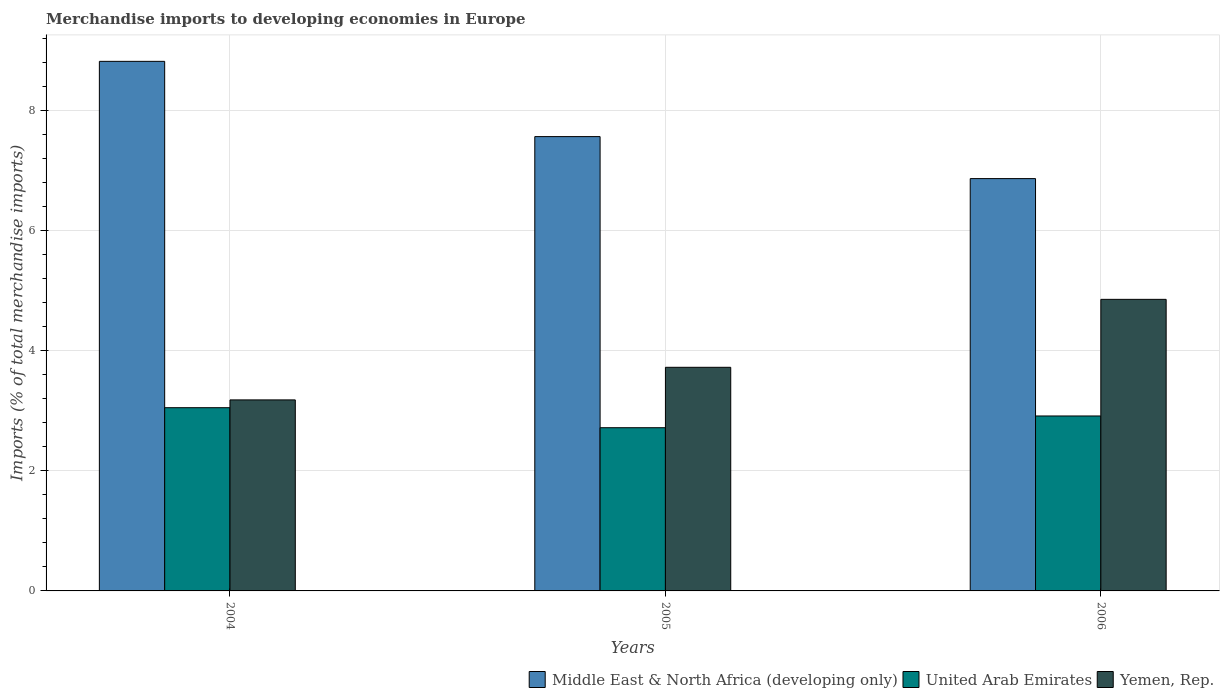How many groups of bars are there?
Offer a terse response. 3. How many bars are there on the 3rd tick from the left?
Provide a succinct answer. 3. How many bars are there on the 3rd tick from the right?
Make the answer very short. 3. What is the percentage total merchandise imports in Middle East & North Africa (developing only) in 2006?
Your response must be concise. 6.87. Across all years, what is the maximum percentage total merchandise imports in Yemen, Rep.?
Your answer should be compact. 4.86. Across all years, what is the minimum percentage total merchandise imports in Yemen, Rep.?
Your answer should be very brief. 3.18. In which year was the percentage total merchandise imports in United Arab Emirates maximum?
Ensure brevity in your answer.  2004. In which year was the percentage total merchandise imports in Middle East & North Africa (developing only) minimum?
Provide a short and direct response. 2006. What is the total percentage total merchandise imports in Yemen, Rep. in the graph?
Keep it short and to the point. 11.76. What is the difference between the percentage total merchandise imports in Middle East & North Africa (developing only) in 2004 and that in 2005?
Your answer should be very brief. 1.25. What is the difference between the percentage total merchandise imports in United Arab Emirates in 2005 and the percentage total merchandise imports in Middle East & North Africa (developing only) in 2004?
Provide a short and direct response. -6.1. What is the average percentage total merchandise imports in Middle East & North Africa (developing only) per year?
Provide a succinct answer. 7.75. In the year 2004, what is the difference between the percentage total merchandise imports in United Arab Emirates and percentage total merchandise imports in Yemen, Rep.?
Ensure brevity in your answer.  -0.13. What is the ratio of the percentage total merchandise imports in Middle East & North Africa (developing only) in 2004 to that in 2006?
Your response must be concise. 1.28. Is the difference between the percentage total merchandise imports in United Arab Emirates in 2005 and 2006 greater than the difference between the percentage total merchandise imports in Yemen, Rep. in 2005 and 2006?
Provide a short and direct response. Yes. What is the difference between the highest and the second highest percentage total merchandise imports in Middle East & North Africa (developing only)?
Give a very brief answer. 1.25. What is the difference between the highest and the lowest percentage total merchandise imports in Yemen, Rep.?
Your answer should be very brief. 1.67. In how many years, is the percentage total merchandise imports in Yemen, Rep. greater than the average percentage total merchandise imports in Yemen, Rep. taken over all years?
Provide a short and direct response. 1. Is the sum of the percentage total merchandise imports in United Arab Emirates in 2005 and 2006 greater than the maximum percentage total merchandise imports in Middle East & North Africa (developing only) across all years?
Provide a succinct answer. No. What does the 1st bar from the left in 2006 represents?
Your answer should be very brief. Middle East & North Africa (developing only). What does the 1st bar from the right in 2006 represents?
Your answer should be compact. Yemen, Rep. Is it the case that in every year, the sum of the percentage total merchandise imports in Yemen, Rep. and percentage total merchandise imports in United Arab Emirates is greater than the percentage total merchandise imports in Middle East & North Africa (developing only)?
Give a very brief answer. No. Are all the bars in the graph horizontal?
Provide a short and direct response. No. What is the difference between two consecutive major ticks on the Y-axis?
Your response must be concise. 2. Are the values on the major ticks of Y-axis written in scientific E-notation?
Your response must be concise. No. How are the legend labels stacked?
Offer a terse response. Horizontal. What is the title of the graph?
Provide a short and direct response. Merchandise imports to developing economies in Europe. Does "Kenya" appear as one of the legend labels in the graph?
Provide a succinct answer. No. What is the label or title of the Y-axis?
Offer a terse response. Imports (% of total merchandise imports). What is the Imports (% of total merchandise imports) of Middle East & North Africa (developing only) in 2004?
Ensure brevity in your answer.  8.82. What is the Imports (% of total merchandise imports) in United Arab Emirates in 2004?
Your answer should be very brief. 3.05. What is the Imports (% of total merchandise imports) in Yemen, Rep. in 2004?
Keep it short and to the point. 3.18. What is the Imports (% of total merchandise imports) in Middle East & North Africa (developing only) in 2005?
Your answer should be compact. 7.57. What is the Imports (% of total merchandise imports) in United Arab Emirates in 2005?
Your response must be concise. 2.72. What is the Imports (% of total merchandise imports) in Yemen, Rep. in 2005?
Provide a short and direct response. 3.72. What is the Imports (% of total merchandise imports) in Middle East & North Africa (developing only) in 2006?
Provide a short and direct response. 6.87. What is the Imports (% of total merchandise imports) in United Arab Emirates in 2006?
Provide a succinct answer. 2.91. What is the Imports (% of total merchandise imports) of Yemen, Rep. in 2006?
Make the answer very short. 4.86. Across all years, what is the maximum Imports (% of total merchandise imports) in Middle East & North Africa (developing only)?
Keep it short and to the point. 8.82. Across all years, what is the maximum Imports (% of total merchandise imports) in United Arab Emirates?
Provide a short and direct response. 3.05. Across all years, what is the maximum Imports (% of total merchandise imports) in Yemen, Rep.?
Make the answer very short. 4.86. Across all years, what is the minimum Imports (% of total merchandise imports) of Middle East & North Africa (developing only)?
Provide a short and direct response. 6.87. Across all years, what is the minimum Imports (% of total merchandise imports) in United Arab Emirates?
Provide a short and direct response. 2.72. Across all years, what is the minimum Imports (% of total merchandise imports) in Yemen, Rep.?
Provide a short and direct response. 3.18. What is the total Imports (% of total merchandise imports) of Middle East & North Africa (developing only) in the graph?
Your answer should be compact. 23.25. What is the total Imports (% of total merchandise imports) of United Arab Emirates in the graph?
Provide a short and direct response. 8.68. What is the total Imports (% of total merchandise imports) of Yemen, Rep. in the graph?
Make the answer very short. 11.76. What is the difference between the Imports (% of total merchandise imports) of Middle East & North Africa (developing only) in 2004 and that in 2005?
Your response must be concise. 1.25. What is the difference between the Imports (% of total merchandise imports) in United Arab Emirates in 2004 and that in 2005?
Your answer should be compact. 0.33. What is the difference between the Imports (% of total merchandise imports) in Yemen, Rep. in 2004 and that in 2005?
Offer a terse response. -0.54. What is the difference between the Imports (% of total merchandise imports) in Middle East & North Africa (developing only) in 2004 and that in 2006?
Ensure brevity in your answer.  1.95. What is the difference between the Imports (% of total merchandise imports) of United Arab Emirates in 2004 and that in 2006?
Keep it short and to the point. 0.14. What is the difference between the Imports (% of total merchandise imports) of Yemen, Rep. in 2004 and that in 2006?
Offer a terse response. -1.67. What is the difference between the Imports (% of total merchandise imports) of Middle East & North Africa (developing only) in 2005 and that in 2006?
Keep it short and to the point. 0.7. What is the difference between the Imports (% of total merchandise imports) of United Arab Emirates in 2005 and that in 2006?
Keep it short and to the point. -0.2. What is the difference between the Imports (% of total merchandise imports) in Yemen, Rep. in 2005 and that in 2006?
Provide a succinct answer. -1.13. What is the difference between the Imports (% of total merchandise imports) of Middle East & North Africa (developing only) in 2004 and the Imports (% of total merchandise imports) of United Arab Emirates in 2005?
Your response must be concise. 6.1. What is the difference between the Imports (% of total merchandise imports) of Middle East & North Africa (developing only) in 2004 and the Imports (% of total merchandise imports) of Yemen, Rep. in 2005?
Offer a very short reply. 5.1. What is the difference between the Imports (% of total merchandise imports) of United Arab Emirates in 2004 and the Imports (% of total merchandise imports) of Yemen, Rep. in 2005?
Keep it short and to the point. -0.67. What is the difference between the Imports (% of total merchandise imports) in Middle East & North Africa (developing only) in 2004 and the Imports (% of total merchandise imports) in United Arab Emirates in 2006?
Your response must be concise. 5.91. What is the difference between the Imports (% of total merchandise imports) of Middle East & North Africa (developing only) in 2004 and the Imports (% of total merchandise imports) of Yemen, Rep. in 2006?
Your answer should be very brief. 3.96. What is the difference between the Imports (% of total merchandise imports) in United Arab Emirates in 2004 and the Imports (% of total merchandise imports) in Yemen, Rep. in 2006?
Offer a very short reply. -1.8. What is the difference between the Imports (% of total merchandise imports) in Middle East & North Africa (developing only) in 2005 and the Imports (% of total merchandise imports) in United Arab Emirates in 2006?
Offer a terse response. 4.65. What is the difference between the Imports (% of total merchandise imports) in Middle East & North Africa (developing only) in 2005 and the Imports (% of total merchandise imports) in Yemen, Rep. in 2006?
Your answer should be very brief. 2.71. What is the difference between the Imports (% of total merchandise imports) of United Arab Emirates in 2005 and the Imports (% of total merchandise imports) of Yemen, Rep. in 2006?
Your response must be concise. -2.14. What is the average Imports (% of total merchandise imports) in Middle East & North Africa (developing only) per year?
Give a very brief answer. 7.75. What is the average Imports (% of total merchandise imports) in United Arab Emirates per year?
Offer a very short reply. 2.89. What is the average Imports (% of total merchandise imports) in Yemen, Rep. per year?
Offer a very short reply. 3.92. In the year 2004, what is the difference between the Imports (% of total merchandise imports) in Middle East & North Africa (developing only) and Imports (% of total merchandise imports) in United Arab Emirates?
Your response must be concise. 5.77. In the year 2004, what is the difference between the Imports (% of total merchandise imports) in Middle East & North Africa (developing only) and Imports (% of total merchandise imports) in Yemen, Rep.?
Ensure brevity in your answer.  5.64. In the year 2004, what is the difference between the Imports (% of total merchandise imports) in United Arab Emirates and Imports (% of total merchandise imports) in Yemen, Rep.?
Provide a succinct answer. -0.13. In the year 2005, what is the difference between the Imports (% of total merchandise imports) in Middle East & North Africa (developing only) and Imports (% of total merchandise imports) in United Arab Emirates?
Offer a very short reply. 4.85. In the year 2005, what is the difference between the Imports (% of total merchandise imports) of Middle East & North Africa (developing only) and Imports (% of total merchandise imports) of Yemen, Rep.?
Ensure brevity in your answer.  3.84. In the year 2005, what is the difference between the Imports (% of total merchandise imports) of United Arab Emirates and Imports (% of total merchandise imports) of Yemen, Rep.?
Give a very brief answer. -1.01. In the year 2006, what is the difference between the Imports (% of total merchandise imports) of Middle East & North Africa (developing only) and Imports (% of total merchandise imports) of United Arab Emirates?
Your answer should be very brief. 3.95. In the year 2006, what is the difference between the Imports (% of total merchandise imports) in Middle East & North Africa (developing only) and Imports (% of total merchandise imports) in Yemen, Rep.?
Your answer should be very brief. 2.01. In the year 2006, what is the difference between the Imports (% of total merchandise imports) of United Arab Emirates and Imports (% of total merchandise imports) of Yemen, Rep.?
Provide a short and direct response. -1.94. What is the ratio of the Imports (% of total merchandise imports) of Middle East & North Africa (developing only) in 2004 to that in 2005?
Offer a terse response. 1.17. What is the ratio of the Imports (% of total merchandise imports) in United Arab Emirates in 2004 to that in 2005?
Offer a terse response. 1.12. What is the ratio of the Imports (% of total merchandise imports) in Yemen, Rep. in 2004 to that in 2005?
Your answer should be compact. 0.85. What is the ratio of the Imports (% of total merchandise imports) in Middle East & North Africa (developing only) in 2004 to that in 2006?
Give a very brief answer. 1.28. What is the ratio of the Imports (% of total merchandise imports) in United Arab Emirates in 2004 to that in 2006?
Your answer should be very brief. 1.05. What is the ratio of the Imports (% of total merchandise imports) of Yemen, Rep. in 2004 to that in 2006?
Offer a very short reply. 0.66. What is the ratio of the Imports (% of total merchandise imports) in Middle East & North Africa (developing only) in 2005 to that in 2006?
Provide a short and direct response. 1.1. What is the ratio of the Imports (% of total merchandise imports) in United Arab Emirates in 2005 to that in 2006?
Offer a very short reply. 0.93. What is the ratio of the Imports (% of total merchandise imports) of Yemen, Rep. in 2005 to that in 2006?
Make the answer very short. 0.77. What is the difference between the highest and the second highest Imports (% of total merchandise imports) of Middle East & North Africa (developing only)?
Make the answer very short. 1.25. What is the difference between the highest and the second highest Imports (% of total merchandise imports) of United Arab Emirates?
Give a very brief answer. 0.14. What is the difference between the highest and the second highest Imports (% of total merchandise imports) of Yemen, Rep.?
Offer a very short reply. 1.13. What is the difference between the highest and the lowest Imports (% of total merchandise imports) in Middle East & North Africa (developing only)?
Keep it short and to the point. 1.95. What is the difference between the highest and the lowest Imports (% of total merchandise imports) in United Arab Emirates?
Give a very brief answer. 0.33. What is the difference between the highest and the lowest Imports (% of total merchandise imports) of Yemen, Rep.?
Make the answer very short. 1.67. 